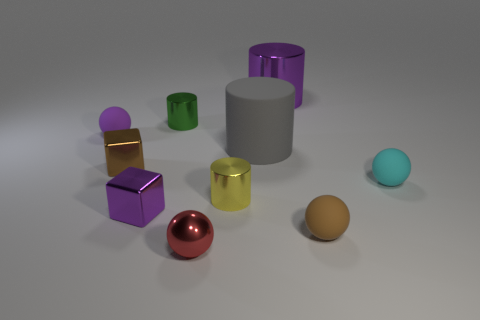Subtract all purple cylinders. How many cylinders are left? 3 Subtract all cylinders. How many objects are left? 6 Subtract 3 cylinders. How many cylinders are left? 1 Subtract all purple spheres. How many spheres are left? 3 Subtract 1 green cylinders. How many objects are left? 9 Subtract all cyan balls. Subtract all cyan cubes. How many balls are left? 3 Subtract all small rubber spheres. Subtract all brown metal objects. How many objects are left? 6 Add 6 small purple matte spheres. How many small purple matte spheres are left? 7 Add 4 yellow objects. How many yellow objects exist? 5 